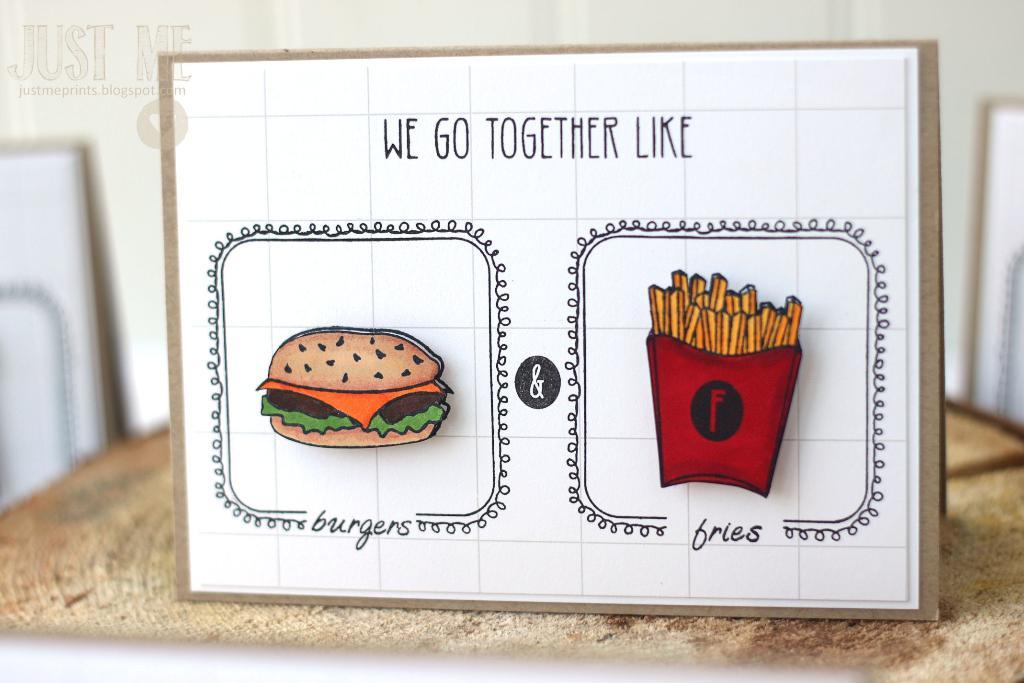What is the main object in the image? There is a board in the image. Where is the board located? The board is placed on a table. What is depicted on the board? There is an image of a burger and fries on the board. What phrase is written on the board? The phrase "we go together like" is written on the board. What type of honey is being used to poison the self in the image? There is no honey, poison, or self present in the image. The image features a board with an image of a burger and fries and a phrase written on it. 